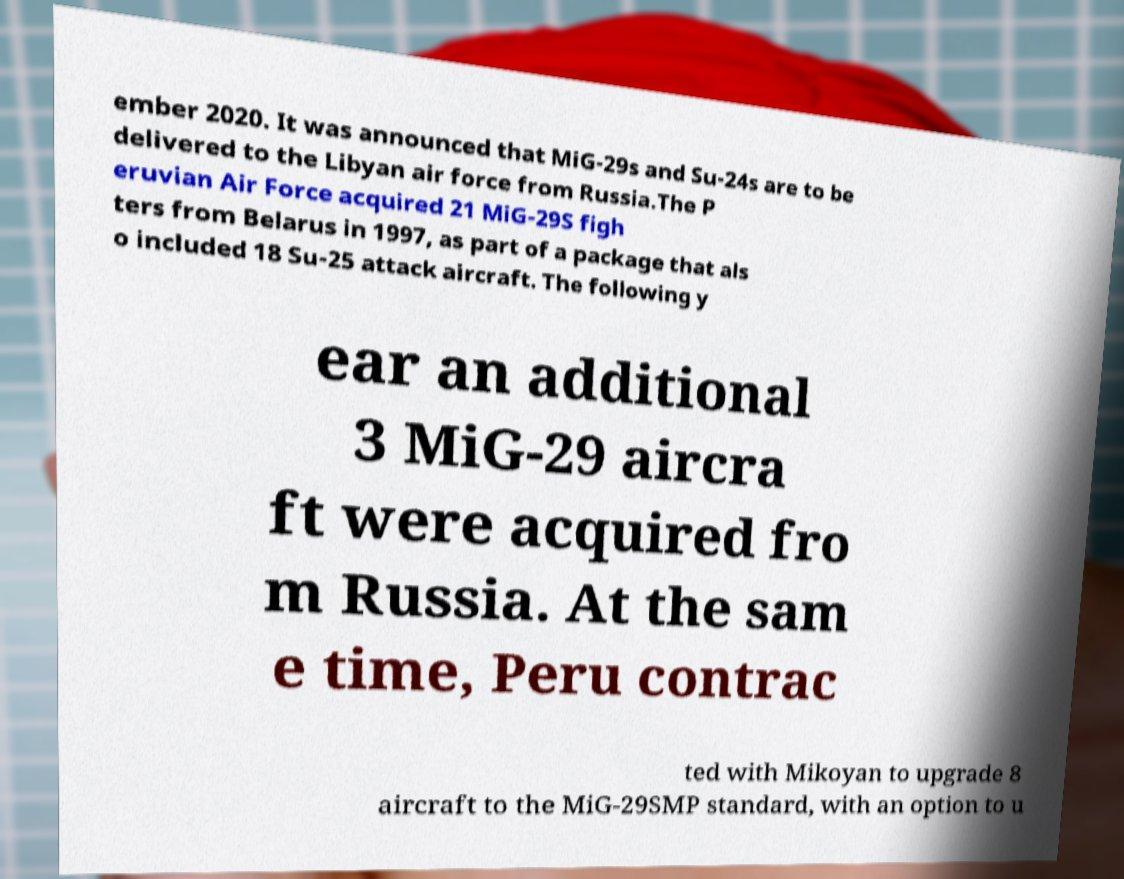There's text embedded in this image that I need extracted. Can you transcribe it verbatim? ember 2020. It was announced that MiG-29s and Su-24s are to be delivered to the Libyan air force from Russia.The P eruvian Air Force acquired 21 MiG-29S figh ters from Belarus in 1997, as part of a package that als o included 18 Su-25 attack aircraft. The following y ear an additional 3 MiG-29 aircra ft were acquired fro m Russia. At the sam e time, Peru contrac ted with Mikoyan to upgrade 8 aircraft to the MiG-29SMP standard, with an option to u 